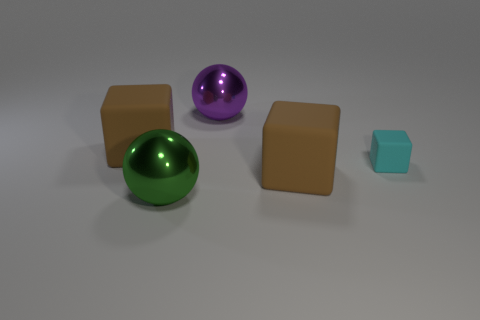What number of big shiny things have the same shape as the small cyan thing?
Make the answer very short. 0. The purple shiny object is what shape?
Provide a short and direct response. Sphere. Is the number of large brown cubes in front of the green object the same as the number of tiny cyan shiny cylinders?
Your answer should be compact. Yes. Is there any other thing that has the same material as the tiny cube?
Give a very brief answer. Yes. Do the brown thing that is left of the green thing and the green sphere have the same material?
Your answer should be very brief. No. Is the number of tiny blocks in front of the green thing less than the number of gray balls?
Offer a terse response. No. What number of metal objects are big brown cubes or cubes?
Offer a terse response. 0. Is there any other thing that has the same color as the small matte object?
Your response must be concise. No. There is a metal object in front of the cyan rubber object; is its shape the same as the big brown thing that is on the left side of the purple metal ball?
Ensure brevity in your answer.  No. What number of objects are tiny cubes or brown rubber cubes that are to the right of the big green shiny ball?
Offer a terse response. 2. 